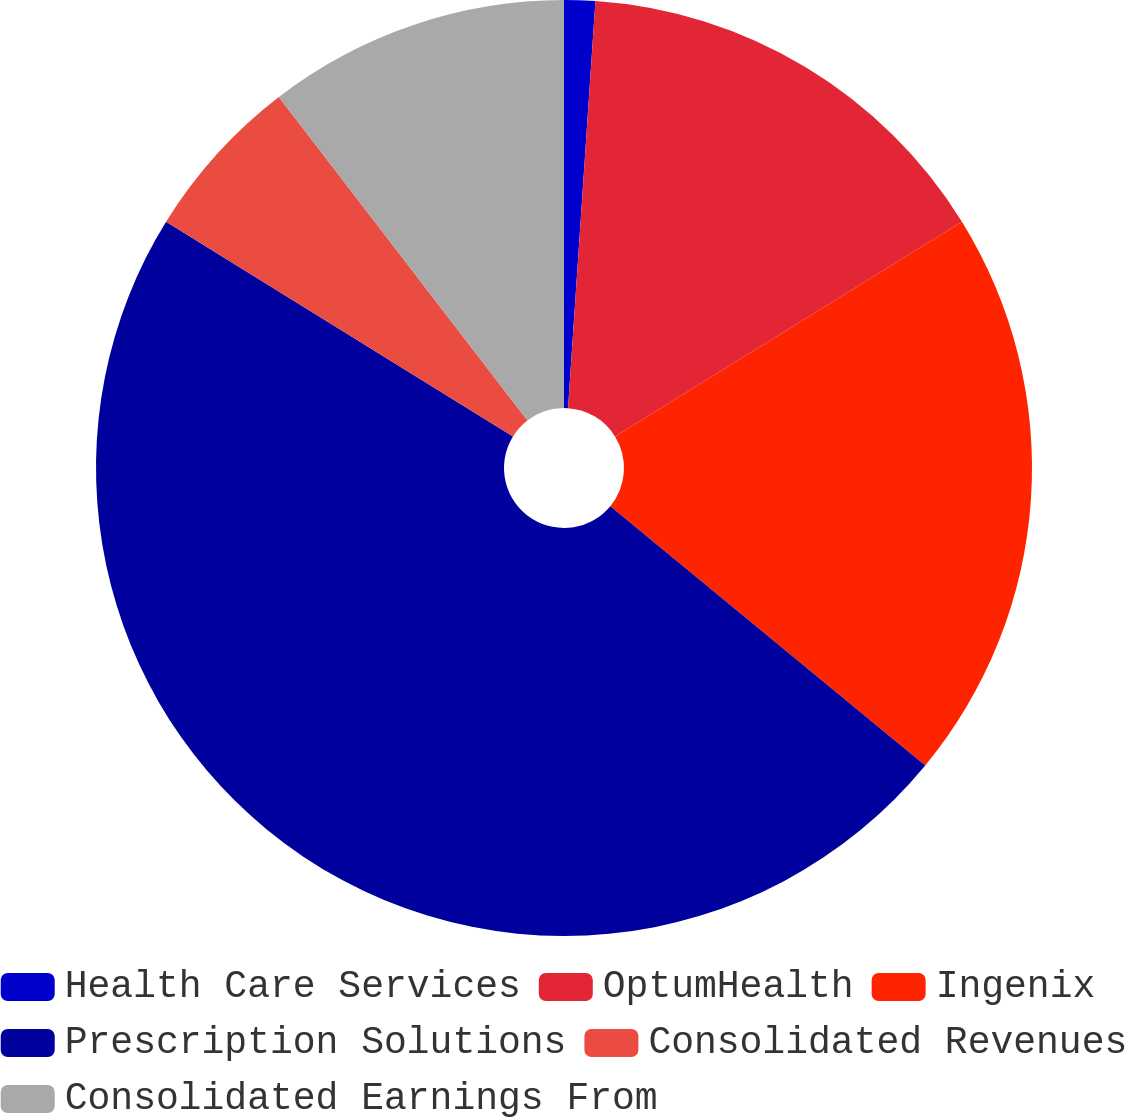Convert chart. <chart><loc_0><loc_0><loc_500><loc_500><pie_chart><fcel>Health Care Services<fcel>OptumHealth<fcel>Ingenix<fcel>Prescription Solutions<fcel>Consolidated Revenues<fcel>Consolidated Earnings From<nl><fcel>1.07%<fcel>15.11%<fcel>19.79%<fcel>47.86%<fcel>5.75%<fcel>10.43%<nl></chart> 